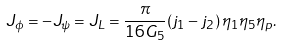<formula> <loc_0><loc_0><loc_500><loc_500>J _ { \phi } = - J _ { \psi } = J _ { L } = \frac { \pi } { 1 6 G _ { 5 } } ( j _ { 1 } - j _ { 2 } ) \, \eta _ { 1 } \eta _ { 5 } \eta _ { p } .</formula> 